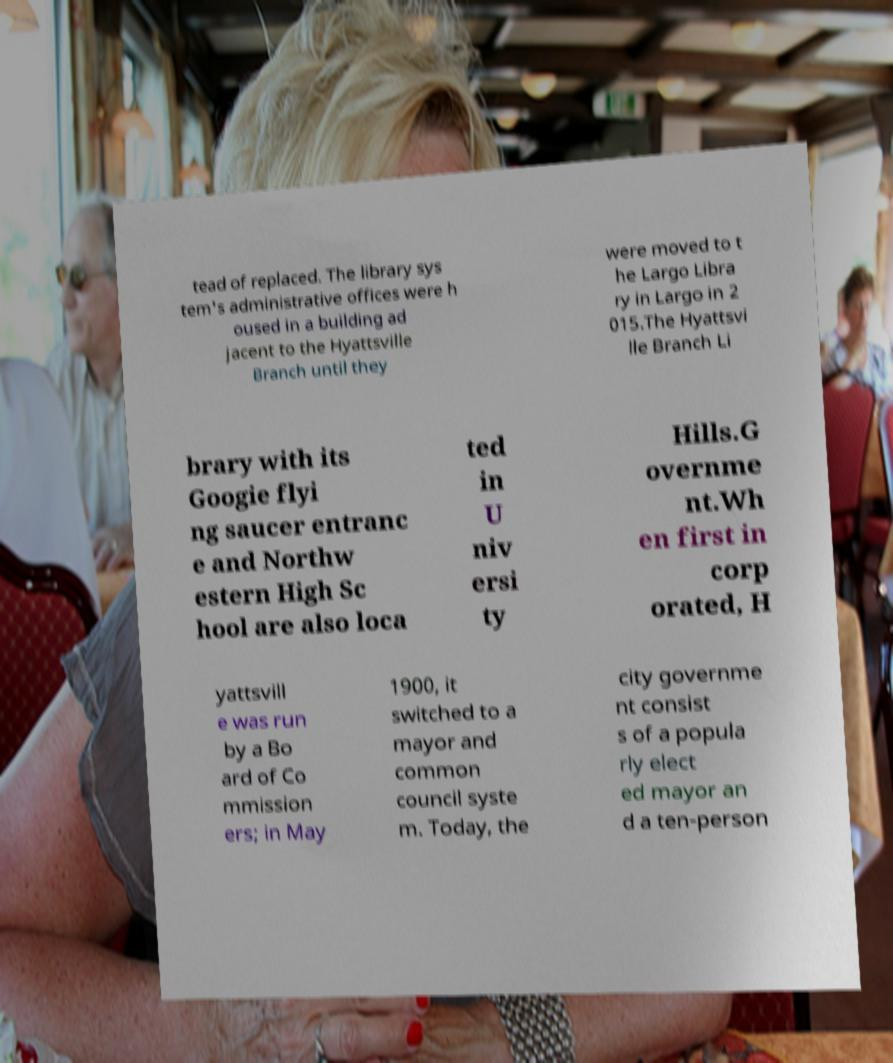Please identify and transcribe the text found in this image. tead of replaced. The library sys tem's administrative offices were h oused in a building ad jacent to the Hyattsville Branch until they were moved to t he Largo Libra ry in Largo in 2 015.The Hyattsvi lle Branch Li brary with its Googie flyi ng saucer entranc e and Northw estern High Sc hool are also loca ted in U niv ersi ty Hills.G overnme nt.Wh en first in corp orated, H yattsvill e was run by a Bo ard of Co mmission ers; in May 1900, it switched to a mayor and common council syste m. Today, the city governme nt consist s of a popula rly elect ed mayor an d a ten-person 